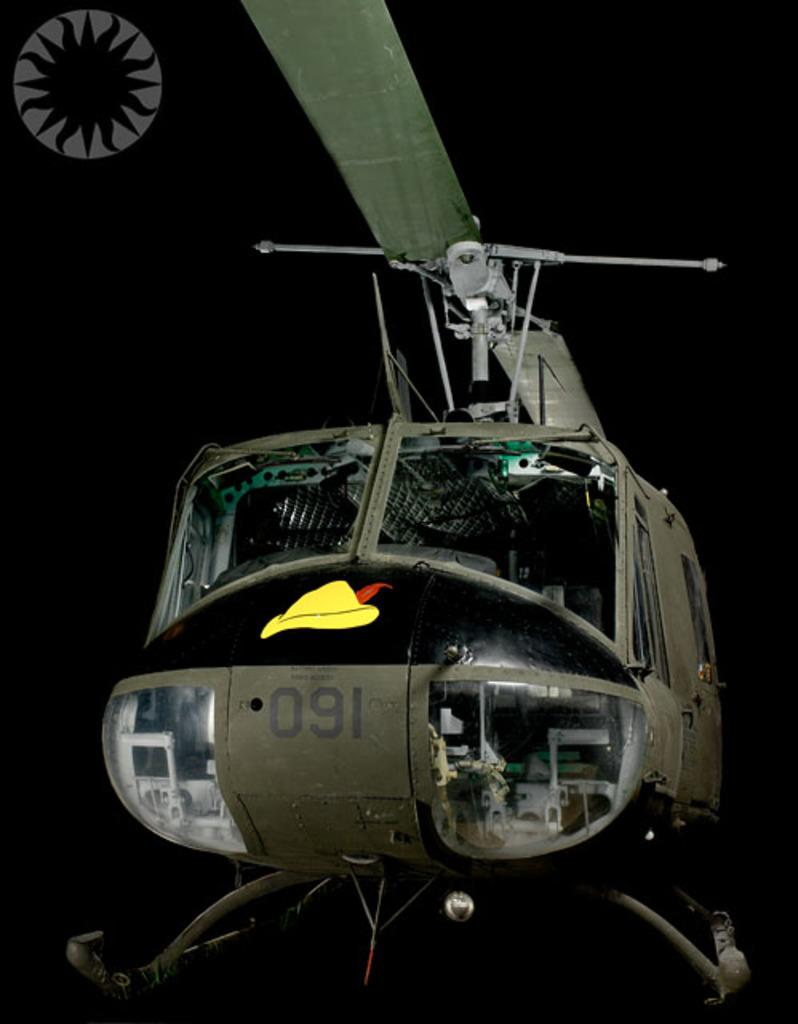<image>
Relay a brief, clear account of the picture shown. A helicopter sitting in the dark with the numbers 091 on its front. 